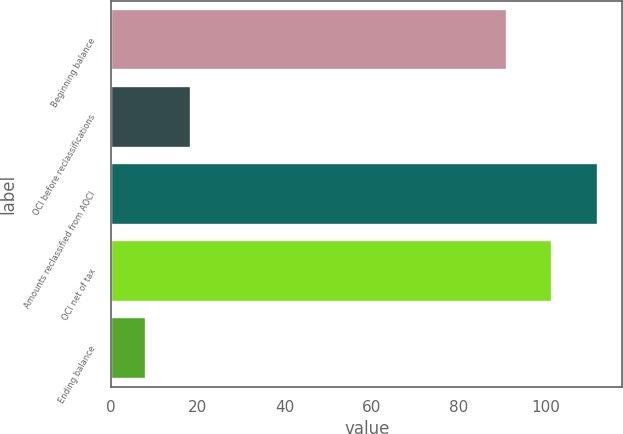<chart> <loc_0><loc_0><loc_500><loc_500><bar_chart><fcel>Beginning balance<fcel>OCI before reclassifications<fcel>Amounts reclassified from AOCI<fcel>OCI net of tax<fcel>Ending balance<nl><fcel>91<fcel>18.4<fcel>112<fcel>101.4<fcel>8<nl></chart> 